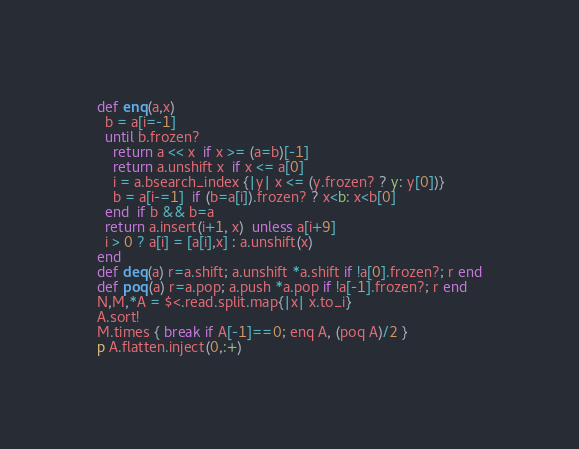Convert code to text. <code><loc_0><loc_0><loc_500><loc_500><_Ruby_>def enq(a,x)
  b = a[i=-1]
  until b.frozen?
    return a << x  if x >= (a=b)[-1]
    return a.unshift x  if x <= a[0]
    i = a.bsearch_index {|y| x <= (y.frozen? ? y: y[0])}
    b = a[i-=1]  if (b=a[i]).frozen? ? x<b: x<b[0]
  end  if b && b=a
  return a.insert(i+1, x)  unless a[i+9]
  i > 0 ? a[i] = [a[i],x] : a.unshift(x)
end
def deq(a) r=a.shift; a.unshift *a.shift if !a[0].frozen?; r end
def poq(a) r=a.pop; a.push *a.pop if !a[-1].frozen?; r end
N,M,*A = $<.read.split.map{|x| x.to_i}
A.sort!
M.times { break if A[-1]==0; enq A, (poq A)/2 }
p A.flatten.inject(0,:+)</code> 